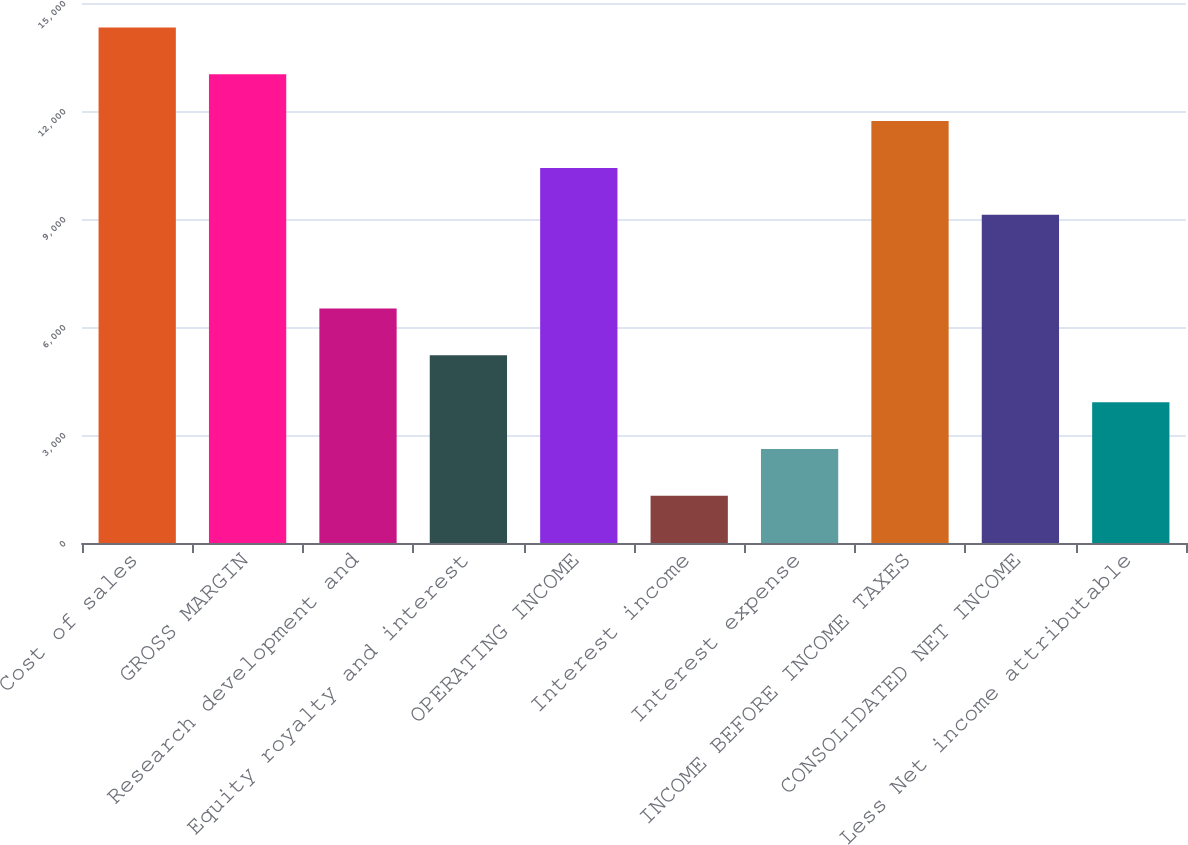Convert chart. <chart><loc_0><loc_0><loc_500><loc_500><bar_chart><fcel>Cost of sales<fcel>GROSS MARGIN<fcel>Research development and<fcel>Equity royalty and interest<fcel>OPERATING INCOME<fcel>Interest income<fcel>Interest expense<fcel>INCOME BEFORE INCOME TAXES<fcel>CONSOLIDATED NET INCOME<fcel>Less Net income attributable<nl><fcel>14322.3<fcel>13021<fcel>6514.46<fcel>5213.15<fcel>10418.4<fcel>1309.22<fcel>2610.53<fcel>11719.7<fcel>9117.08<fcel>3911.84<nl></chart> 